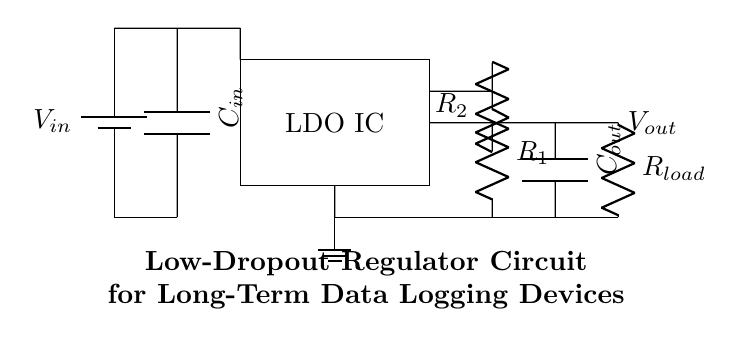What is the value of the input capacitor? The input capacitor is labeled as C_in, but its value is not specified in the diagram.
Answer: C_in What type of circuit is shown in this diagram? The circuit diagram presents a low-dropout regulator (LDO) used to provide a stable output voltage from a varying input voltage.
Answer: Low-dropout regulator What is connected to the output pin? The output pin connects to a load resistor, which is labeled as R_load in the circuit.
Answer: R_load What is the purpose of the feedback resistors R1 and R2? R1 and R2 form a voltage divider that allows the LDO to regulate the output voltage by providing feedback to the LDO IC.
Answer: Voltage regulation What is the relationship between input and output voltage? A low-dropout regulator is designed to maintain the output voltage close to the input voltage, with a minimal difference required for proper operation.
Answer: Minimal voltage difference What components are essential for stability in this LDO circuit? The components essential for stability are the input capacitor (C_in) and the output capacitor (C_out), which help filter any voltage fluctuations.
Answer: C_in and C_out What is the expected behavior of the LDO under varying load conditions? The LDO is designed to maintain a constant output voltage despite changes in load current, providing stable performance for the connected data logging device.
Answer: Constant output voltage 